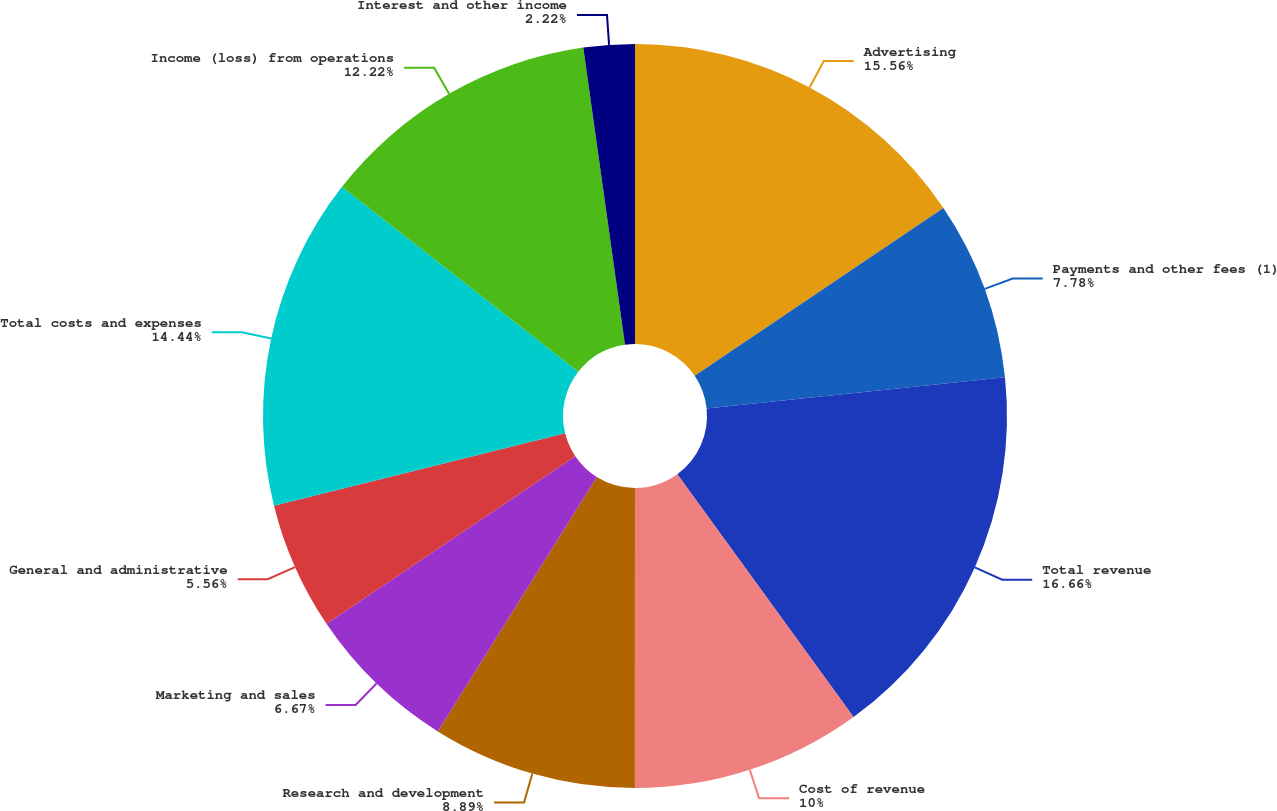<chart> <loc_0><loc_0><loc_500><loc_500><pie_chart><fcel>Advertising<fcel>Payments and other fees (1)<fcel>Total revenue<fcel>Cost of revenue<fcel>Research and development<fcel>Marketing and sales<fcel>General and administrative<fcel>Total costs and expenses<fcel>Income (loss) from operations<fcel>Interest and other income<nl><fcel>15.56%<fcel>7.78%<fcel>16.67%<fcel>10.0%<fcel>8.89%<fcel>6.67%<fcel>5.56%<fcel>14.44%<fcel>12.22%<fcel>2.22%<nl></chart> 